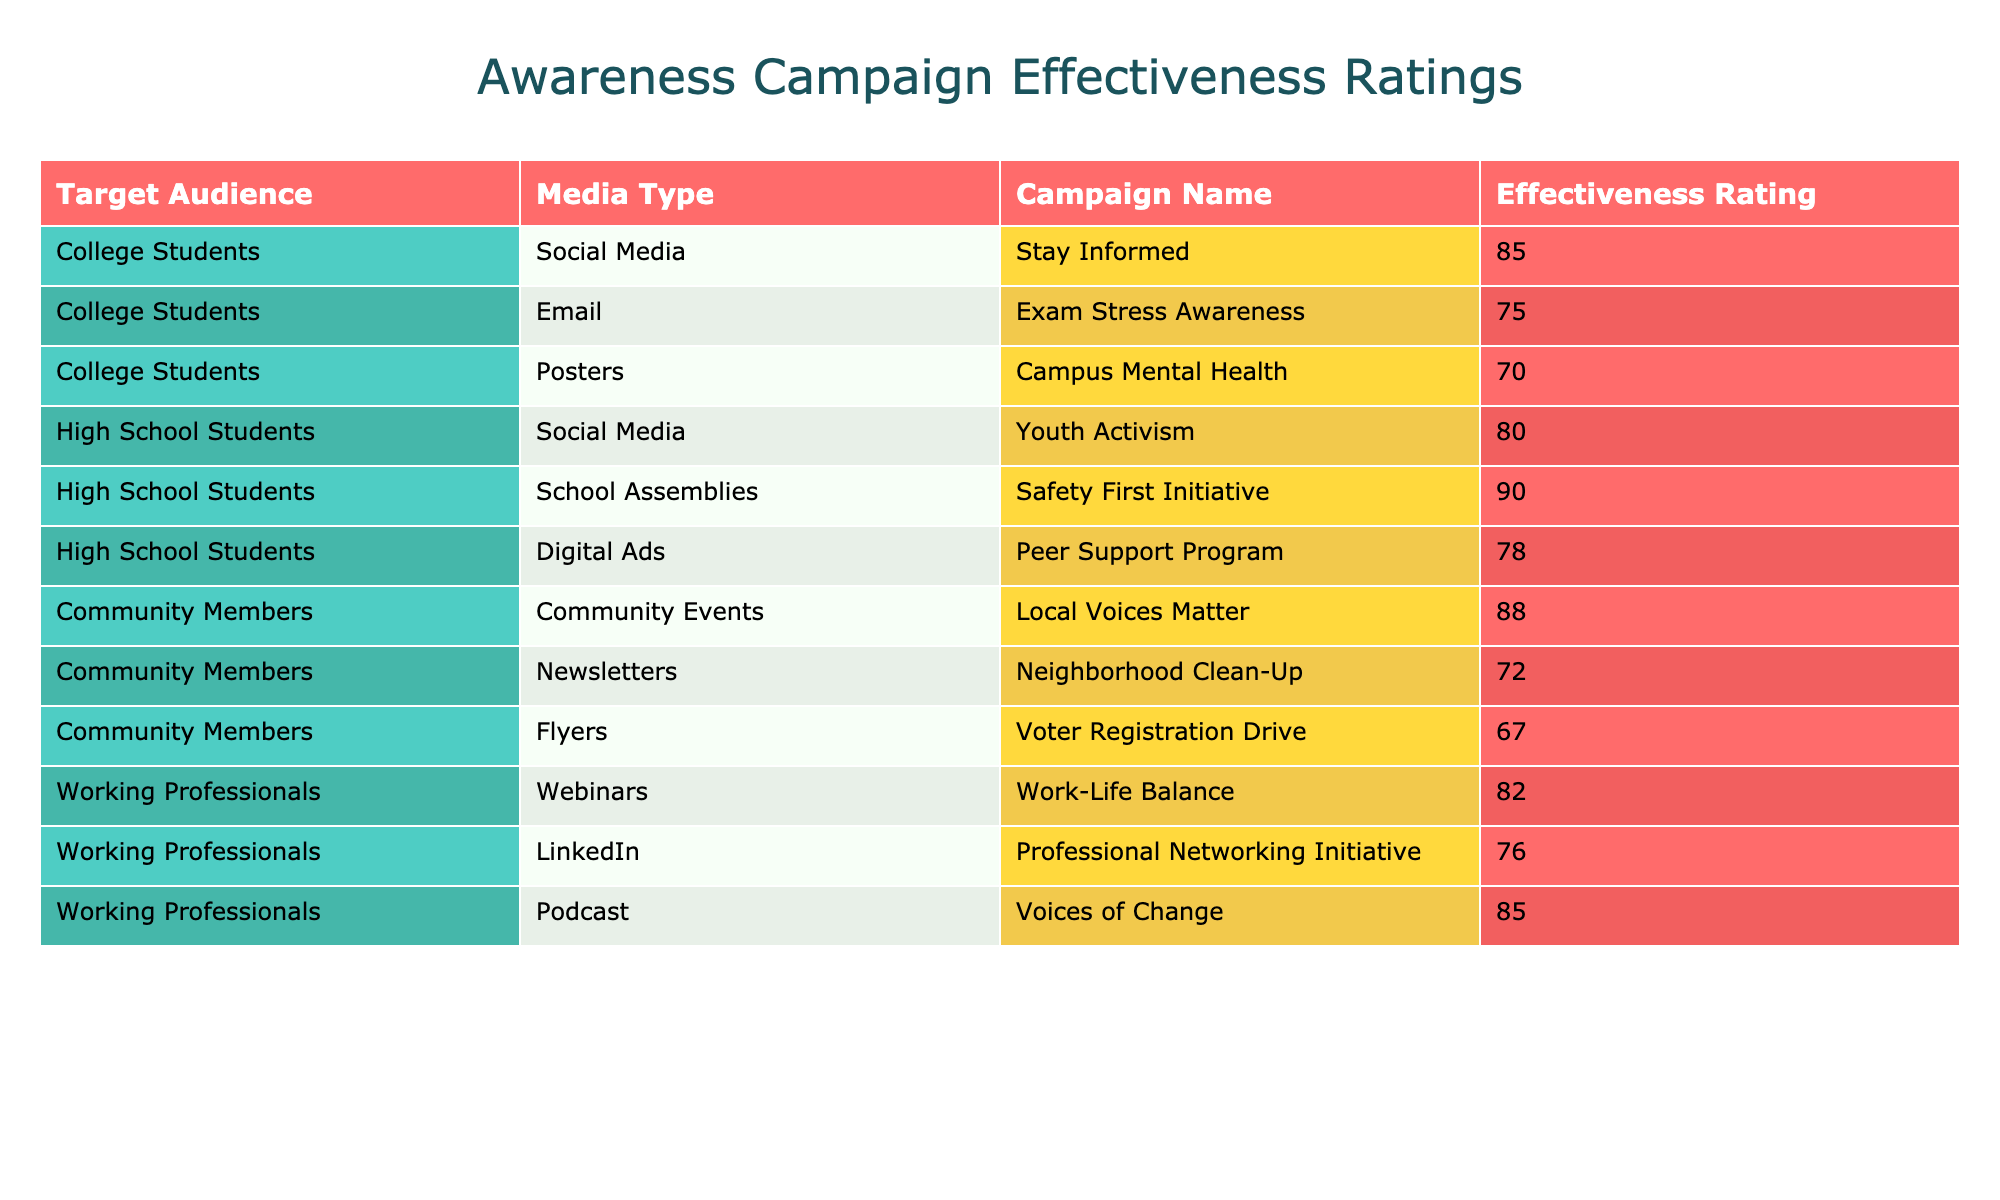What is the effectiveness rating for the "Exam Stress Awareness" campaign targeting College Students? The table shows that the effectiveness rating for the "Exam Stress Awareness" campaign, which targets College Students, is listed under the corresponding row. It specifically states the effectiveness rating as 75.
Answer: 75 Which media type has the highest effectiveness rating for High School Students? Looking at the rows targeting High School Students, the effectiveness ratings for each media type are: Social Media (80), School Assemblies (90), and Digital Ads (78). The highest among these is for School Assemblies, which has an effectiveness rating of 90.
Answer: School Assemblies What is the average effectiveness rating for campaigns targeting Community Members? The effectiveness ratings for Community Members are: Local Voices Matter (88), Neighborhood Clean-Up (72), and Voter Registration Drive (67). To find the average, sum these values: 88 + 72 + 67 = 227, then divide by 3 (the number of campaigns): 227 / 3 = 75.67.
Answer: 75.67 Is the effectiveness rating for "Voices of Change" higher than 80? The table shows that the effectiveness rating for the "Voices of Change" campaign is 85. Since 85 is greater than 80, the statement is true.
Answer: Yes Which target audience has the lowest average effectiveness rating? First, we calculate the average effectiveness rating for each target audience. College Students: (85 + 75 + 70) / 3 = 76.67, High School Students: (80 + 90 + 78) / 3 = 82.67, Community Members: (88 + 72 + 67) / 3 = 75.67, Working Professionals: (82 + 76 + 85) / 3 = 81. So the lowest average is for Community Members, which is 75.67.
Answer: Community Members 